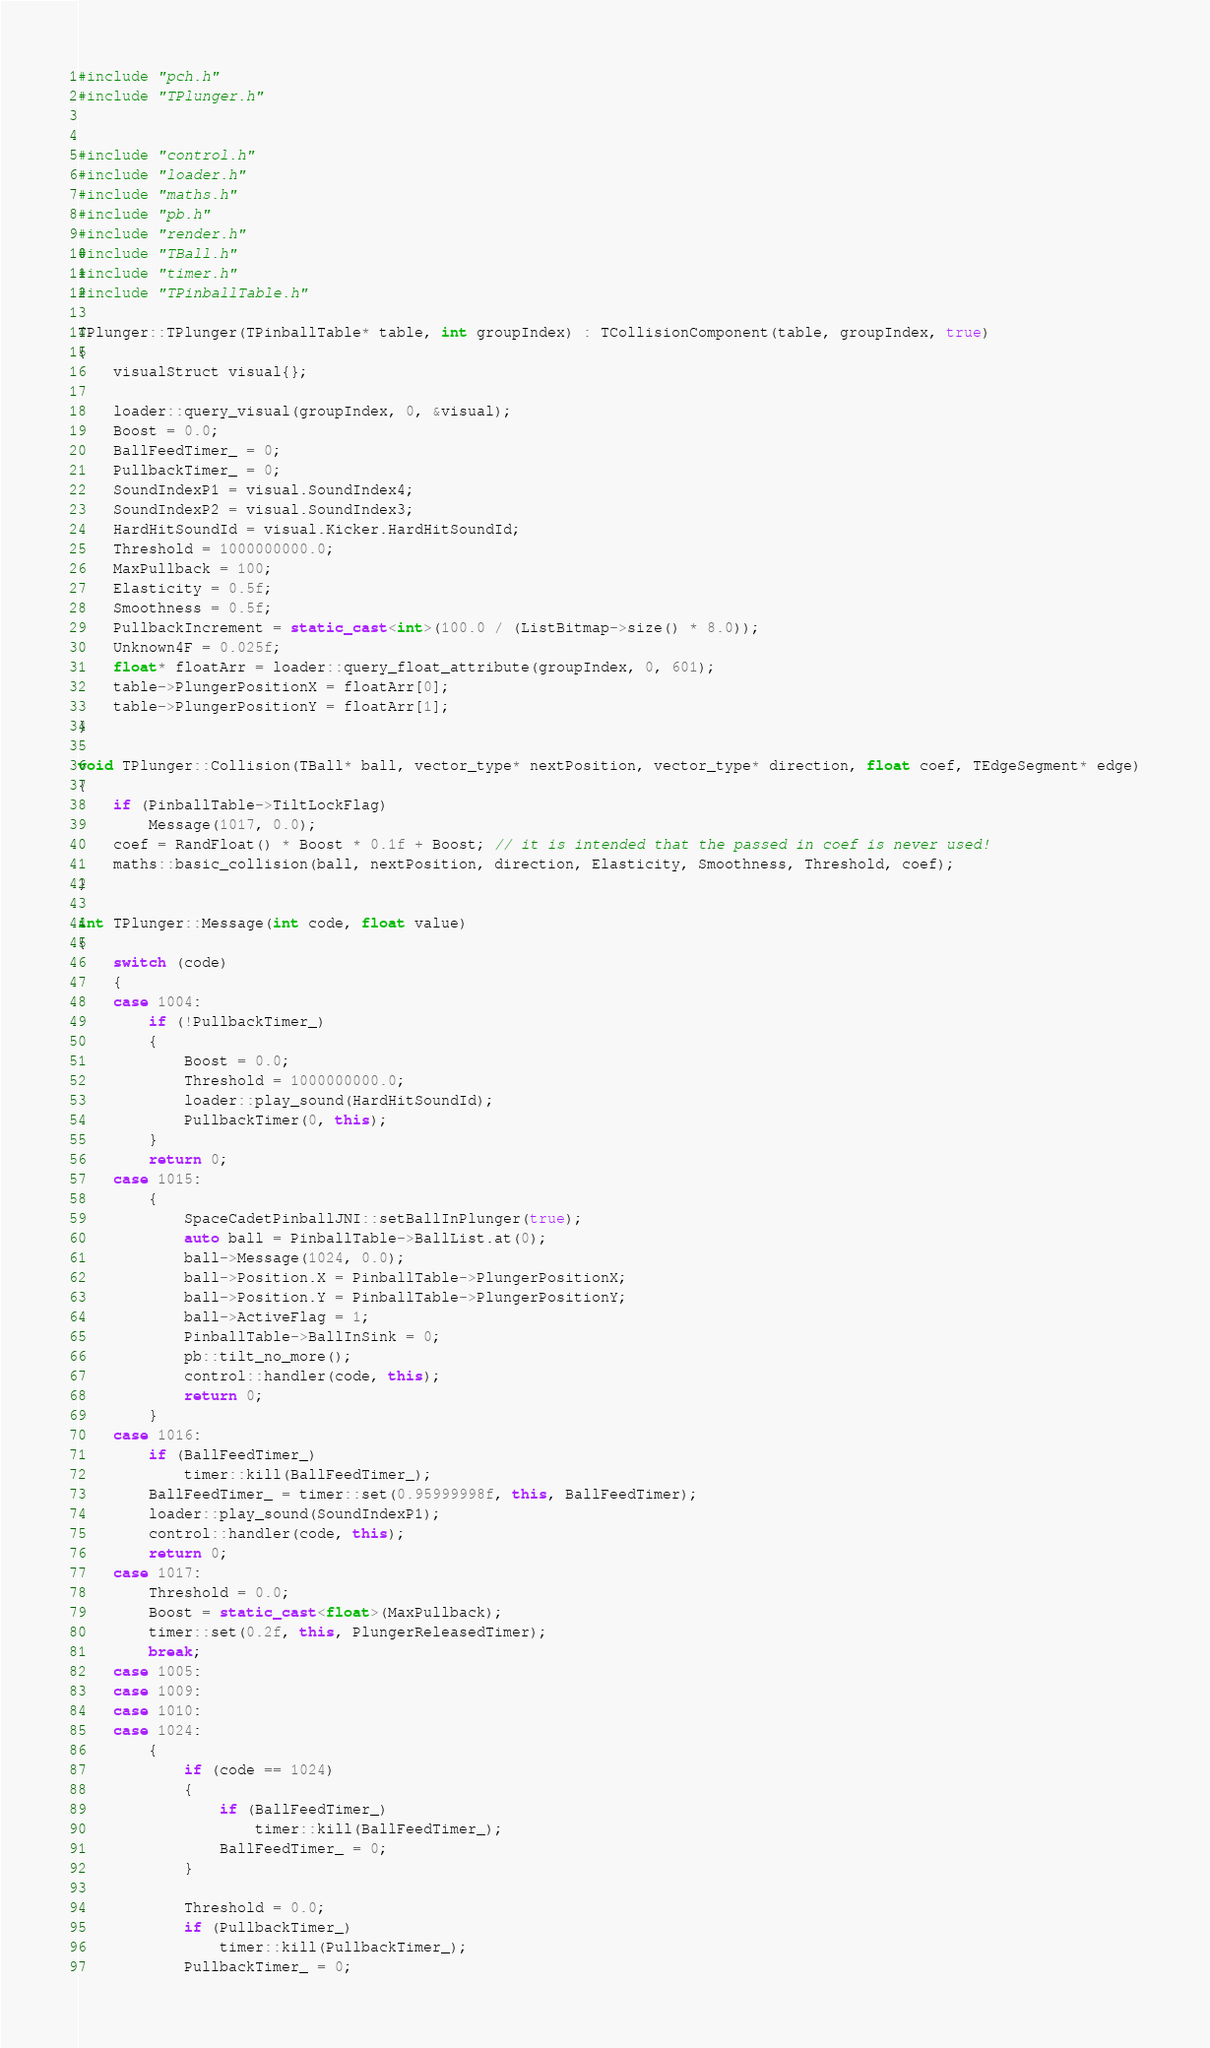Convert code to text. <code><loc_0><loc_0><loc_500><loc_500><_C++_>#include "pch.h"
#include "TPlunger.h"


#include "control.h"
#include "loader.h"
#include "maths.h"
#include "pb.h"
#include "render.h"
#include "TBall.h"
#include "timer.h"
#include "TPinballTable.h"

TPlunger::TPlunger(TPinballTable* table, int groupIndex) : TCollisionComponent(table, groupIndex, true)
{
	visualStruct visual{};

	loader::query_visual(groupIndex, 0, &visual);
	Boost = 0.0;
	BallFeedTimer_ = 0;
	PullbackTimer_ = 0;
	SoundIndexP1 = visual.SoundIndex4;
	SoundIndexP2 = visual.SoundIndex3;
	HardHitSoundId = visual.Kicker.HardHitSoundId;
	Threshold = 1000000000.0;
	MaxPullback = 100;
	Elasticity = 0.5f;
	Smoothness = 0.5f;
	PullbackIncrement = static_cast<int>(100.0 / (ListBitmap->size() * 8.0));
	Unknown4F = 0.025f;
	float* floatArr = loader::query_float_attribute(groupIndex, 0, 601);
	table->PlungerPositionX = floatArr[0];
	table->PlungerPositionY = floatArr[1];
}

void TPlunger::Collision(TBall* ball, vector_type* nextPosition, vector_type* direction, float coef, TEdgeSegment* edge)
{
	if (PinballTable->TiltLockFlag)
		Message(1017, 0.0);
	coef = RandFloat() * Boost * 0.1f + Boost; // it is intended that the passed in coef is never used!
	maths::basic_collision(ball, nextPosition, direction, Elasticity, Smoothness, Threshold, coef);
}

int TPlunger::Message(int code, float value)
{
	switch (code)
	{
	case 1004:
		if (!PullbackTimer_)
		{
			Boost = 0.0;
			Threshold = 1000000000.0;
			loader::play_sound(HardHitSoundId);
			PullbackTimer(0, this);
		}
		return 0;
	case 1015:
		{
            SpaceCadetPinballJNI::setBallInPlunger(true);
            auto ball = PinballTable->BallList.at(0);
			ball->Message(1024, 0.0);
			ball->Position.X = PinballTable->PlungerPositionX;
			ball->Position.Y = PinballTable->PlungerPositionY;
			ball->ActiveFlag = 1;
			PinballTable->BallInSink = 0;
			pb::tilt_no_more();
			control::handler(code, this);
			return 0;
		}
	case 1016:
		if (BallFeedTimer_)
			timer::kill(BallFeedTimer_);
		BallFeedTimer_ = timer::set(0.95999998f, this, BallFeedTimer);
		loader::play_sound(SoundIndexP1);
		control::handler(code, this);
		return 0;
	case 1017:
		Threshold = 0.0;
		Boost = static_cast<float>(MaxPullback);
		timer::set(0.2f, this, PlungerReleasedTimer);
		break;
	case 1005:
	case 1009:
	case 1010:
	case 1024:
		{
			if (code == 1024)
			{
				if (BallFeedTimer_)
					timer::kill(BallFeedTimer_);
				BallFeedTimer_ = 0;
			}

			Threshold = 0.0;
			if (PullbackTimer_)
				timer::kill(PullbackTimer_);
			PullbackTimer_ = 0;</code> 